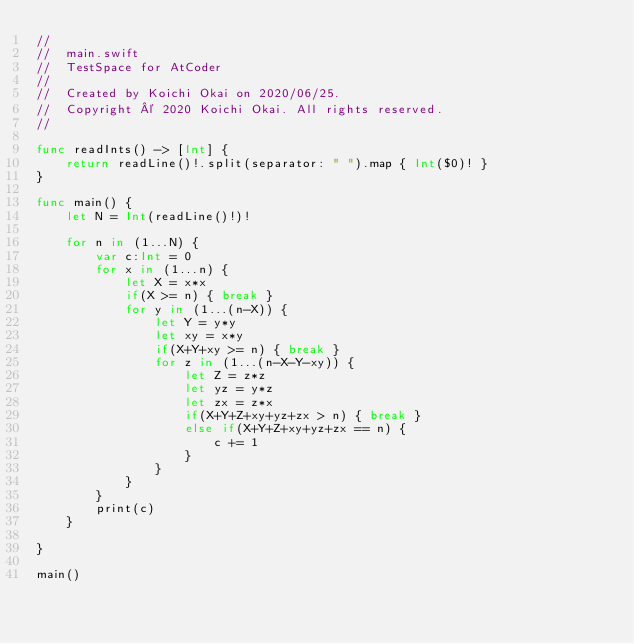<code> <loc_0><loc_0><loc_500><loc_500><_Swift_>//
//  main.swift
//  TestSpace for AtCoder
//
//  Created by Koichi Okai on 2020/06/25.
//  Copyright © 2020 Koichi Okai. All rights reserved.
//

func readInts() -> [Int] {
    return readLine()!.split(separator: " ").map { Int($0)! }
}

func main() {
    let N = Int(readLine()!)!
    
    for n in (1...N) {
        var c:Int = 0
        for x in (1...n) {
            let X = x*x
            if(X >= n) { break }
            for y in (1...(n-X)) {
                let Y = y*y
                let xy = x*y
                if(X+Y+xy >= n) { break }
                for z in (1...(n-X-Y-xy)) {
                    let Z = z*z
                    let yz = y*z
                    let zx = z*x
                    if(X+Y+Z+xy+yz+zx > n) { break }
                    else if(X+Y+Z+xy+yz+zx == n) {
                        c += 1
                    }
                }
            }
        }
        print(c)
    }
    
}

main()
</code> 